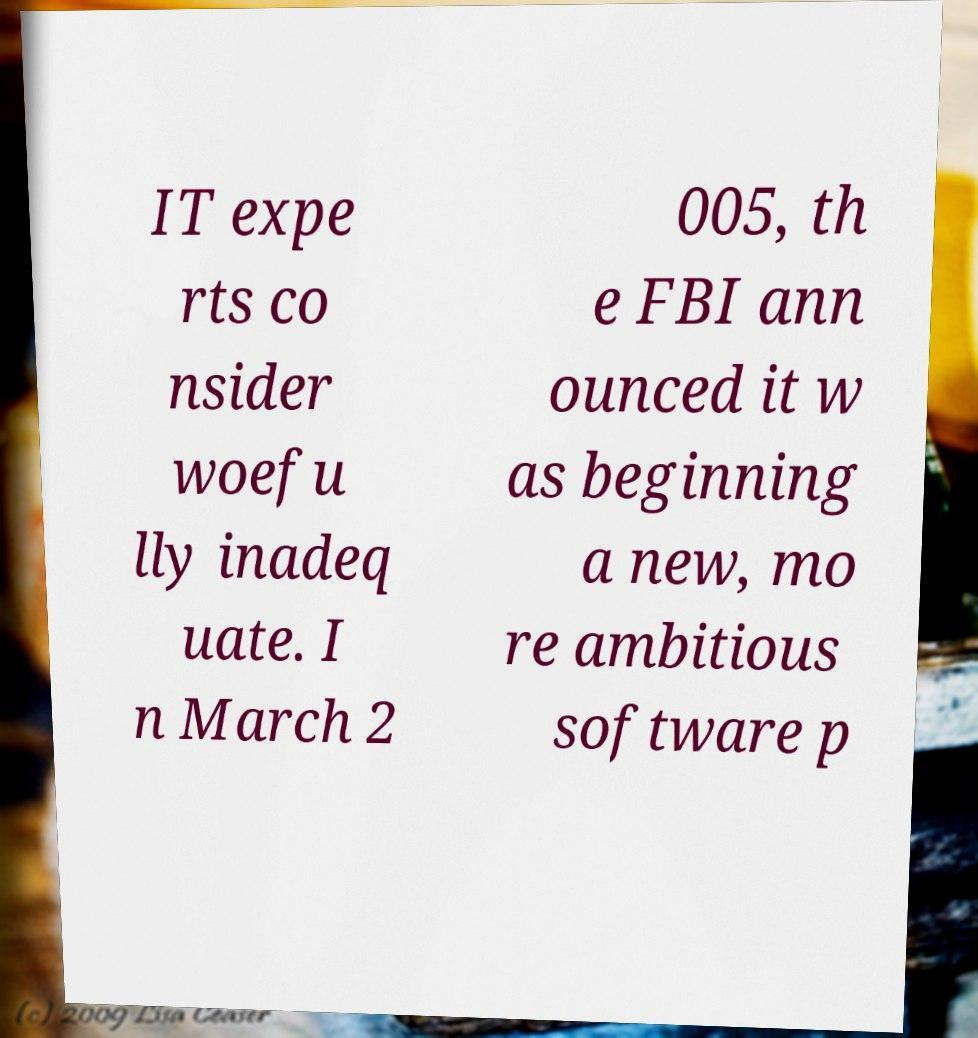Could you extract and type out the text from this image? IT expe rts co nsider woefu lly inadeq uate. I n March 2 005, th e FBI ann ounced it w as beginning a new, mo re ambitious software p 